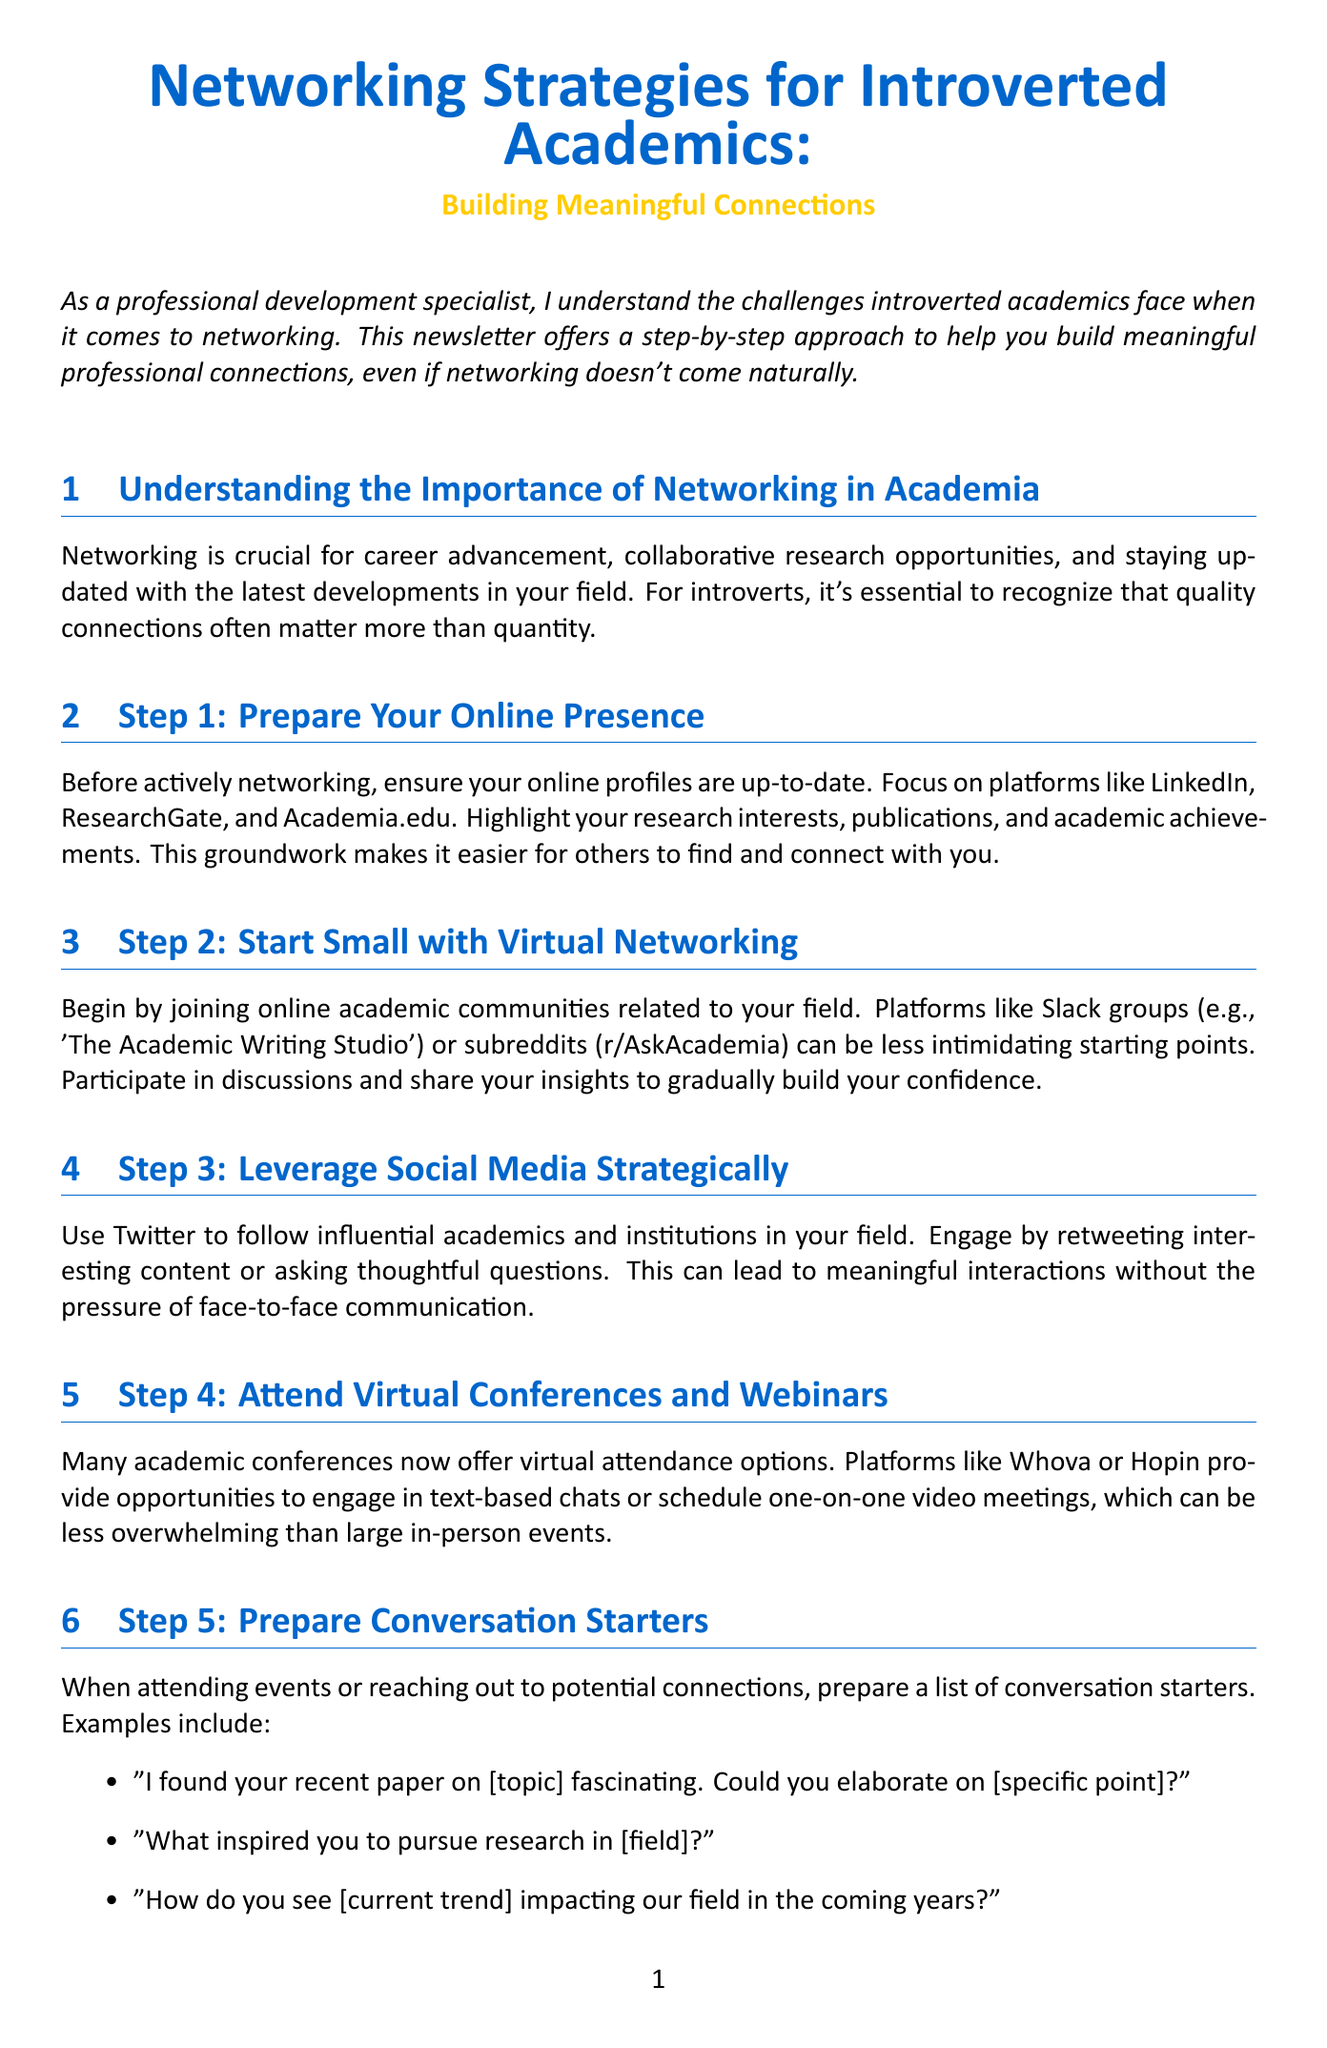What is the title of the newsletter? The title can be found at the beginning of the document and indicates the main topic covered.
Answer: Networking Strategies for Introverted Academics: Building Meaningful Connections Who is the intended audience of the newsletter? The introduction specifies that the newsletter is aimed at introverted academics, highlighting the challenges they face.
Answer: Introverted academics What is a suggested platform for virtual networking? Step 2 mentions specific online communities ideal for networking, giving examples that are relevant to academics.
Answer: Slack groups What is the first step in building your online presence? Step 1 outlines the initial action necessary for effective networking by focusing on online profiles.
Answer: Ensure your online profiles are up-to-date Name one type of conversation starter provided. In Step 5, several examples of conversation starters are listed for engaging with potential connections.
Answer: I found your recent paper on [topic] fascinating. Could you elaborate on [specific point]? What is the purpose of attending virtual conferences? Step 4 outlines how virtual conferences offer a less overwhelming networking option for academics.
Answer: Engage in text-based chats What should you focus on when participating in virtual discussions? Step 9 emphasizes a crucial skill that introverted academics should develop during online interactions.
Answer: Active listening What is the final piece of advice given in the conclusion? The conclusion summarizes the overarching theme of developing networking skills over time, highlighting a specific strength of introverted academics.
Answer: Build a strong professional network What action is suggested for those looking for personalized guidance? The call to action at the end encourages a specific step for individuals seeking tailored support.
Answer: Reach out for a one-on-one consultation 